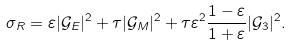<formula> <loc_0><loc_0><loc_500><loc_500>\sigma _ { R } = \varepsilon | \mathcal { G } _ { E } | ^ { 2 } + \tau | \mathcal { G } _ { M } | ^ { 2 } + \tau \varepsilon ^ { 2 } \frac { 1 - \varepsilon } { 1 + \varepsilon } | \mathcal { G } _ { 3 } | ^ { 2 } .</formula> 